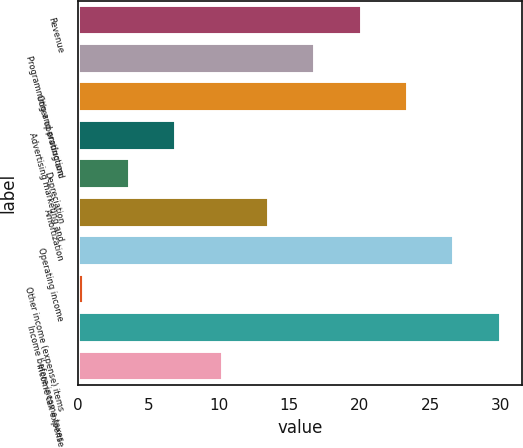<chart> <loc_0><loc_0><loc_500><loc_500><bar_chart><fcel>Revenue<fcel>Programming and production<fcel>Other operating and<fcel>Advertising marketing and<fcel>Depreciation<fcel>Amortization<fcel>Operating income<fcel>Other income (expense) items<fcel>Income before income taxes<fcel>Income tax expense<nl><fcel>20.14<fcel>16.85<fcel>23.43<fcel>6.98<fcel>3.69<fcel>13.56<fcel>26.72<fcel>0.4<fcel>30.01<fcel>10.27<nl></chart> 